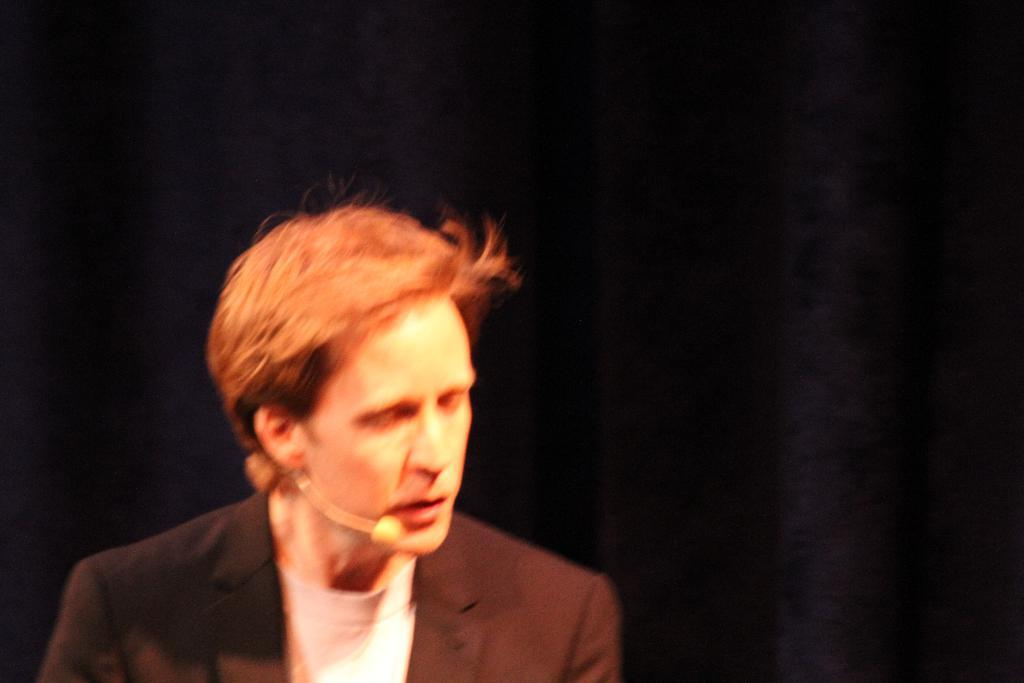What is the main subject of the image? The main subject of the image is a man. What is the man holding in the image? The man is holding a mic in the image. What is the man doing with the mic? The man is talking while holding the mic. What can be observed about the background of the image? The background of the image is dark. Is the man blowing out candles on a birthday cake in the image? No, there is no birthday cake or candles present in the image. What type of stove is visible in the image? There is no stove present in the image. 